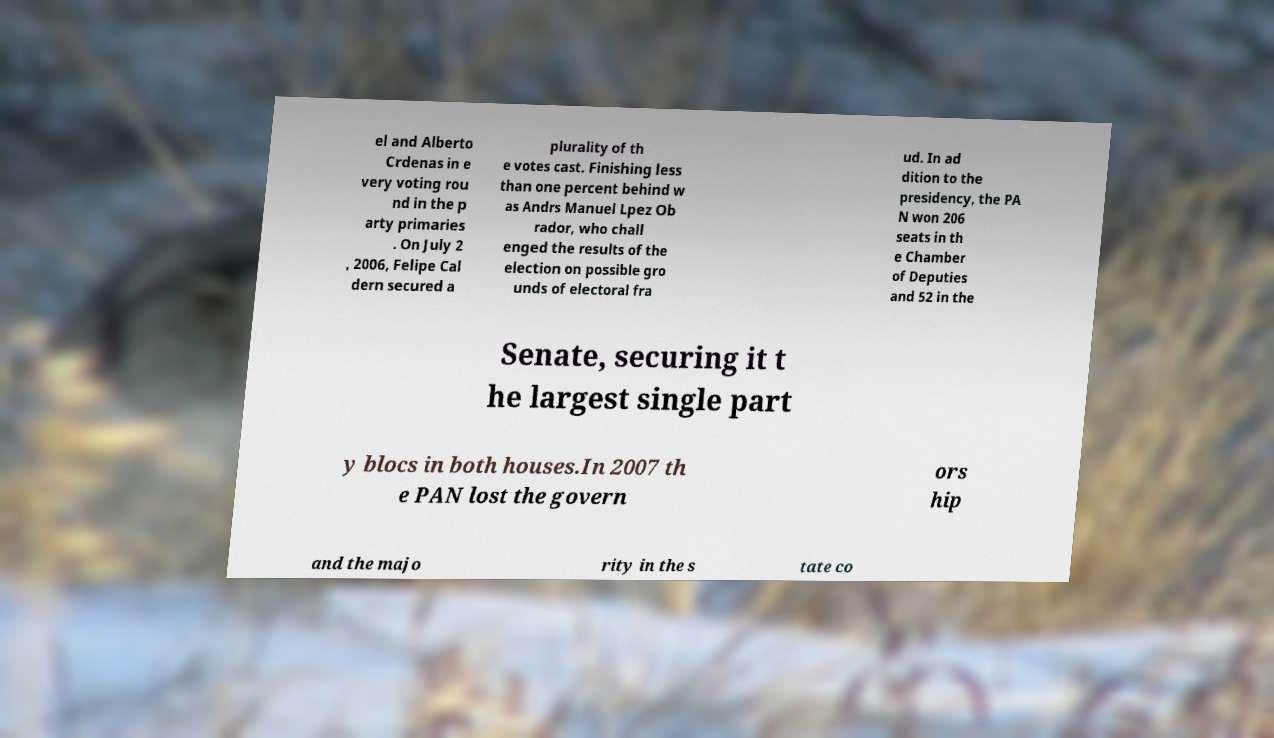Could you assist in decoding the text presented in this image and type it out clearly? el and Alberto Crdenas in e very voting rou nd in the p arty primaries . On July 2 , 2006, Felipe Cal dern secured a plurality of th e votes cast. Finishing less than one percent behind w as Andrs Manuel Lpez Ob rador, who chall enged the results of the election on possible gro unds of electoral fra ud. In ad dition to the presidency, the PA N won 206 seats in th e Chamber of Deputies and 52 in the Senate, securing it t he largest single part y blocs in both houses.In 2007 th e PAN lost the govern ors hip and the majo rity in the s tate co 